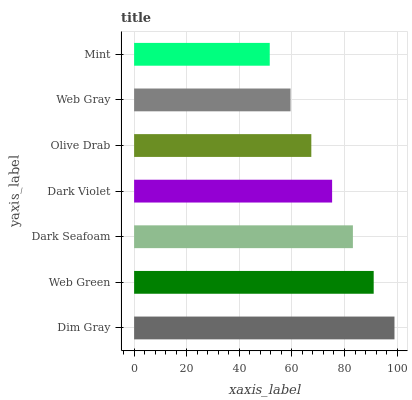Is Mint the minimum?
Answer yes or no. Yes. Is Dim Gray the maximum?
Answer yes or no. Yes. Is Web Green the minimum?
Answer yes or no. No. Is Web Green the maximum?
Answer yes or no. No. Is Dim Gray greater than Web Green?
Answer yes or no. Yes. Is Web Green less than Dim Gray?
Answer yes or no. Yes. Is Web Green greater than Dim Gray?
Answer yes or no. No. Is Dim Gray less than Web Green?
Answer yes or no. No. Is Dark Violet the high median?
Answer yes or no. Yes. Is Dark Violet the low median?
Answer yes or no. Yes. Is Web Green the high median?
Answer yes or no. No. Is Dim Gray the low median?
Answer yes or no. No. 